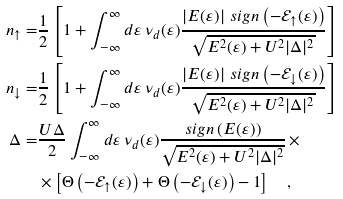<formula> <loc_0><loc_0><loc_500><loc_500>n _ { \uparrow } = & \frac { 1 } { 2 } \left [ 1 + \int _ { - \infty } ^ { \infty } d \varepsilon \, \nu _ { d } ( \varepsilon ) \frac { \left | E ( \varepsilon ) \right | \, s i g n \left ( - \mathcal { E } _ { \uparrow } ( \varepsilon ) \right ) } { \sqrt { E ^ { 2 } ( \varepsilon ) + U ^ { 2 } | \Delta | ^ { 2 } } } \right ] \\ n _ { \downarrow } = & \frac { 1 } { 2 } \left [ 1 + \int _ { - \infty } ^ { \infty } d \varepsilon \, \nu _ { d } ( \varepsilon ) \frac { \left | E ( \varepsilon ) \right | \, s i g n \left ( - \mathcal { E } _ { \downarrow } ( \varepsilon ) \right ) } { \sqrt { E ^ { 2 } ( \varepsilon ) + U ^ { 2 } | \Delta | ^ { 2 } } } \right ] \\ \Delta = & \frac { U \Delta } { 2 } \int _ { - \infty } ^ { \infty } d \varepsilon \, \nu _ { d } ( \varepsilon ) \frac { s i g n \left ( E ( \varepsilon ) \right ) } { \sqrt { E ^ { 2 } ( \varepsilon ) + U ^ { 2 } | \Delta | ^ { 2 } } } \, \times \\ & \times \left [ \Theta \left ( - \mathcal { E } _ { \uparrow } ( \varepsilon ) \right ) + \Theta \left ( - \mathcal { E } _ { \downarrow } ( \varepsilon ) \right ) - 1 \right ] \quad ,</formula> 